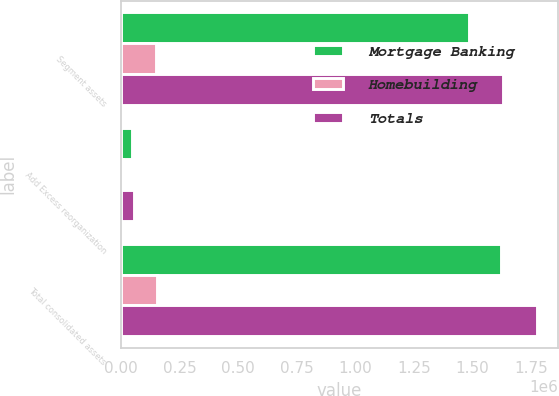Convert chart. <chart><loc_0><loc_0><loc_500><loc_500><stacked_bar_chart><ecel><fcel>Segment assets<fcel>Add Excess reorganization<fcel>Total consolidated assets<nl><fcel>Mortgage Banking<fcel>1.48508e+06<fcel>47959<fcel>1.62297e+06<nl><fcel>Homebuilding<fcel>147652<fcel>7347<fcel>154999<nl><fcel>Totals<fcel>1.63274e+06<fcel>55306<fcel>1.77797e+06<nl></chart> 